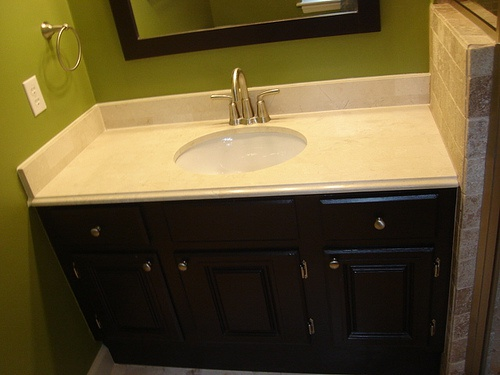Describe the objects in this image and their specific colors. I can see a sink in olive, tan, and lightgray tones in this image. 